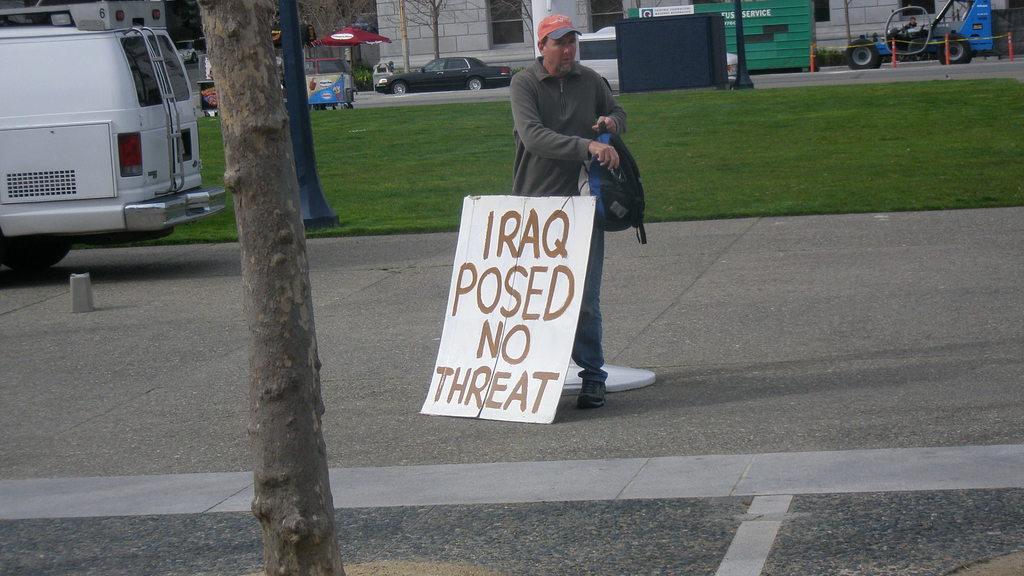Describe this image in one or two sentences. In the middle of the image a man carrying bag is standing wearing cap , jacket. In front of him there is a board. In the foreground there is a tree. On the left there is a van. In the background there are buildings, vehicles, trees, umbrella,tent and few other things are there. 